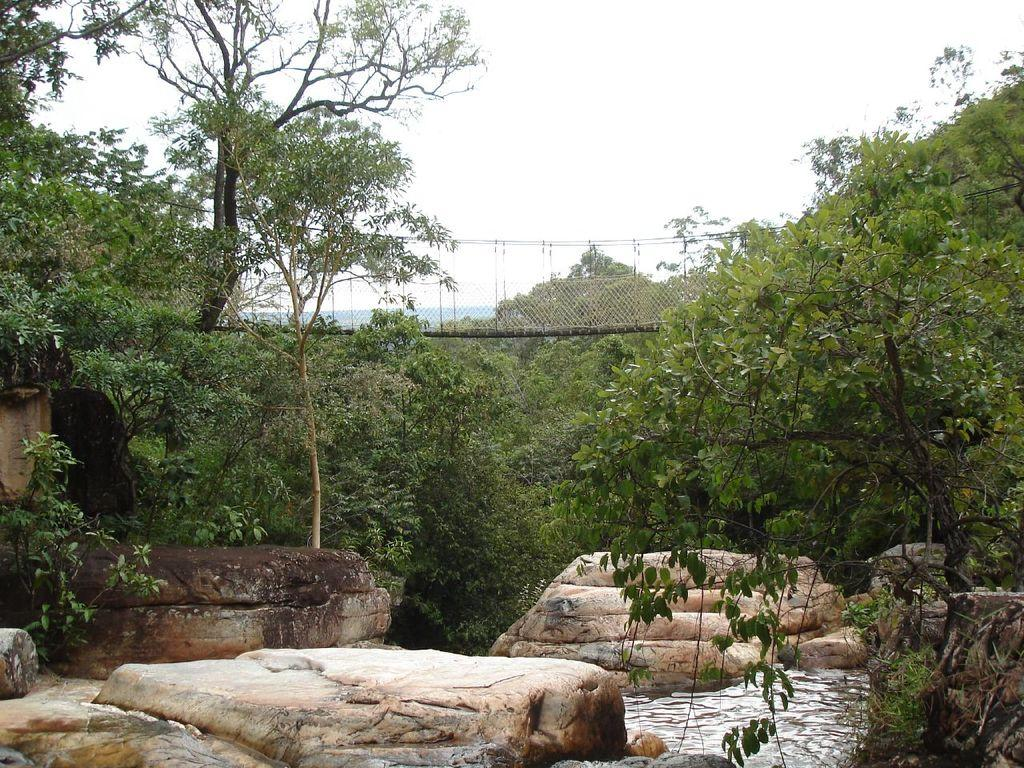What type of natural elements can be seen in the image? There are stones, trees, plants, and water visible in the image. What man-made structure is present in the image? There is a bridge in the image. What part of the natural environment is visible in the image? The sky is visible in the image. What type of tray can be seen holding the basket in the image? There is no tray or basket present in the image. How is the whip being used in the image? There is no whip present in the image. 